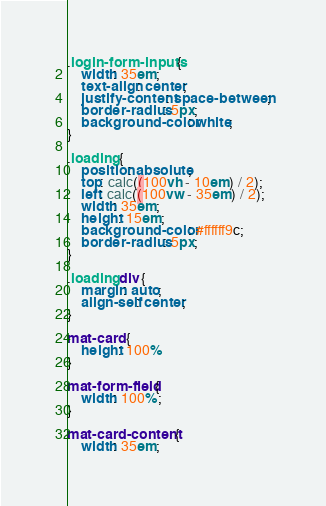<code> <loc_0><loc_0><loc_500><loc_500><_CSS_>.login-form-inputs {
    width: 35em;
    text-align: center;
    justify-content: space-between;
    border-radius: 5px;
    background-color: white;
}

.loading {
    position: absolute;
    top: calc((100vh - 10em) / 2);
    left: calc((100vw - 35em) / 2);
    width: 35em;
    height: 15em;
    background-color: #ffffff9c;
    border-radius: 5px;
}

.loading div {
    margin: auto;
    align-self: center;
}

mat-card {
    height: 100%
}

mat-form-field {
    width: 100%;
}

mat-card-content {
    width: 35em;</code> 